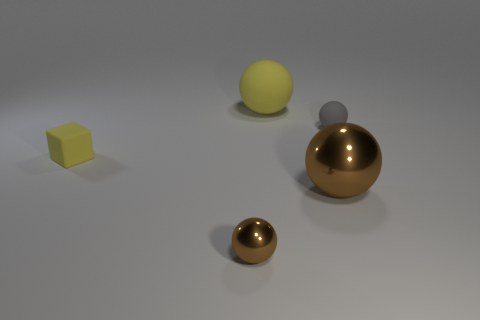What shape is the tiny metallic object that is the same color as the large metallic thing?
Your answer should be compact. Sphere. What number of tiny rubber blocks have the same color as the large rubber sphere?
Offer a very short reply. 1. There is a shiny object that is behind the tiny brown ball; does it have the same shape as the small rubber object to the left of the big rubber sphere?
Make the answer very short. No. There is a brown metallic object in front of the big brown ball on the left side of the tiny matte ball; what number of brown metallic balls are on the right side of it?
Make the answer very short. 1. There is a small ball behind the small brown sphere that is in front of the yellow rubber thing in front of the small rubber sphere; what is its material?
Keep it short and to the point. Rubber. Is the material of the big sphere behind the tiny gray rubber object the same as the big brown object?
Your response must be concise. No. What number of matte things have the same size as the yellow rubber sphere?
Provide a short and direct response. 0. Is the number of small gray objects to the left of the small rubber ball greater than the number of spheres behind the tiny yellow object?
Ensure brevity in your answer.  No. Are there any small yellow things of the same shape as the small brown object?
Offer a terse response. No. What is the size of the brown object behind the tiny thing in front of the small yellow block?
Provide a succinct answer. Large. 